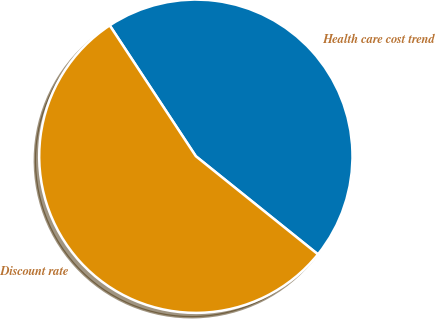<chart> <loc_0><loc_0><loc_500><loc_500><pie_chart><fcel>Health care cost trend<fcel>Discount rate<nl><fcel>45.04%<fcel>54.96%<nl></chart> 